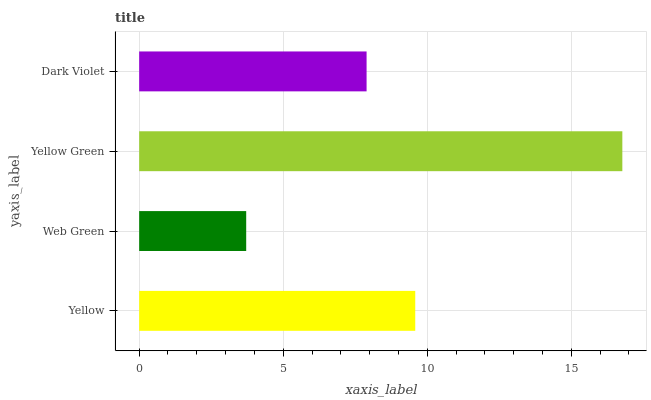Is Web Green the minimum?
Answer yes or no. Yes. Is Yellow Green the maximum?
Answer yes or no. Yes. Is Yellow Green the minimum?
Answer yes or no. No. Is Web Green the maximum?
Answer yes or no. No. Is Yellow Green greater than Web Green?
Answer yes or no. Yes. Is Web Green less than Yellow Green?
Answer yes or no. Yes. Is Web Green greater than Yellow Green?
Answer yes or no. No. Is Yellow Green less than Web Green?
Answer yes or no. No. Is Yellow the high median?
Answer yes or no. Yes. Is Dark Violet the low median?
Answer yes or no. Yes. Is Dark Violet the high median?
Answer yes or no. No. Is Yellow Green the low median?
Answer yes or no. No. 